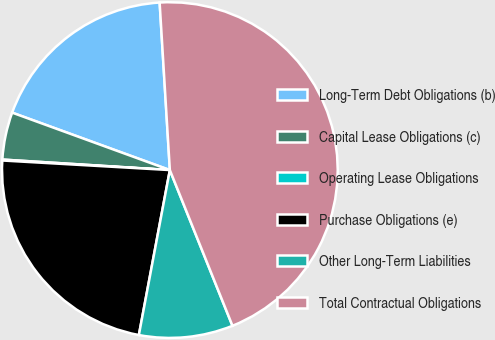Convert chart to OTSL. <chart><loc_0><loc_0><loc_500><loc_500><pie_chart><fcel>Long-Term Debt Obligations (b)<fcel>Capital Lease Obligations (c)<fcel>Operating Lease Obligations<fcel>Purchase Obligations (e)<fcel>Other Long-Term Liabilities<fcel>Total Contractual Obligations<nl><fcel>18.47%<fcel>4.56%<fcel>0.09%<fcel>22.95%<fcel>9.04%<fcel>44.88%<nl></chart> 